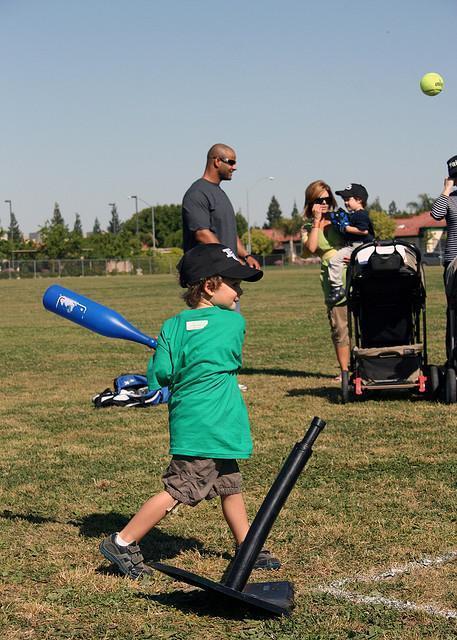How many sunglasses?
Give a very brief answer. 2. How many people are visible?
Give a very brief answer. 5. How many bicycle helmets are contain the color yellow?
Give a very brief answer. 0. 